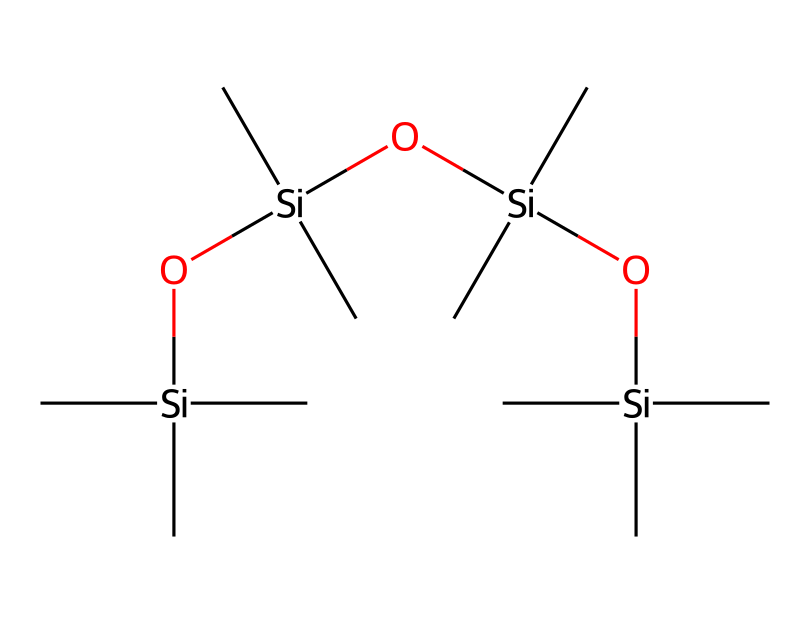How many silicon atoms are present in the structure? The SMILES representation indicates each silicon atom is represented by the element 'Si'. By observing the string, we can count each occurrence of 'Si', which appears 4 times in this structure.
Answer: 4 What functional group is represented in the chemical structure? In the SMILES notation, the presence of the 'O' atoms indicates the presence of silanol groups (-Si-OH) or siloxane linkages. The O atoms connected to Si atoms suggest this functional aspect, confirming the existence of siloxane groups in this molecule.
Answer: siloxane How many carbon atoms are connected to the silicon atoms? By examining the SMILES structure, we find that each silicon atom is bonded to three carbon atoms. Since there are 4 silicon atoms, we multiply 4 by 3, resulting in a total of 12 carbon atoms.
Answer: 12 What is the overall molecular structure type of this chemical? Upon analyzing the connectivity in the chemical, the structure consists solely of silicon, carbon, and oxygen atoms arranged in siloxane linkages, which indicates that this chemical is a silane-based compound and designed for surface coatings.
Answer: silane Does this chemical have hydrophobic properties? The presence of multiple silicon and carbon atoms coupled with the siloxane structures typically results in hydrophobic characteristics. Silanes are known for their water-repellent properties, especially in applications such as outdoor equipment coatings, leading to the conclusion of hydrophobicity.
Answer: hydrophobic 